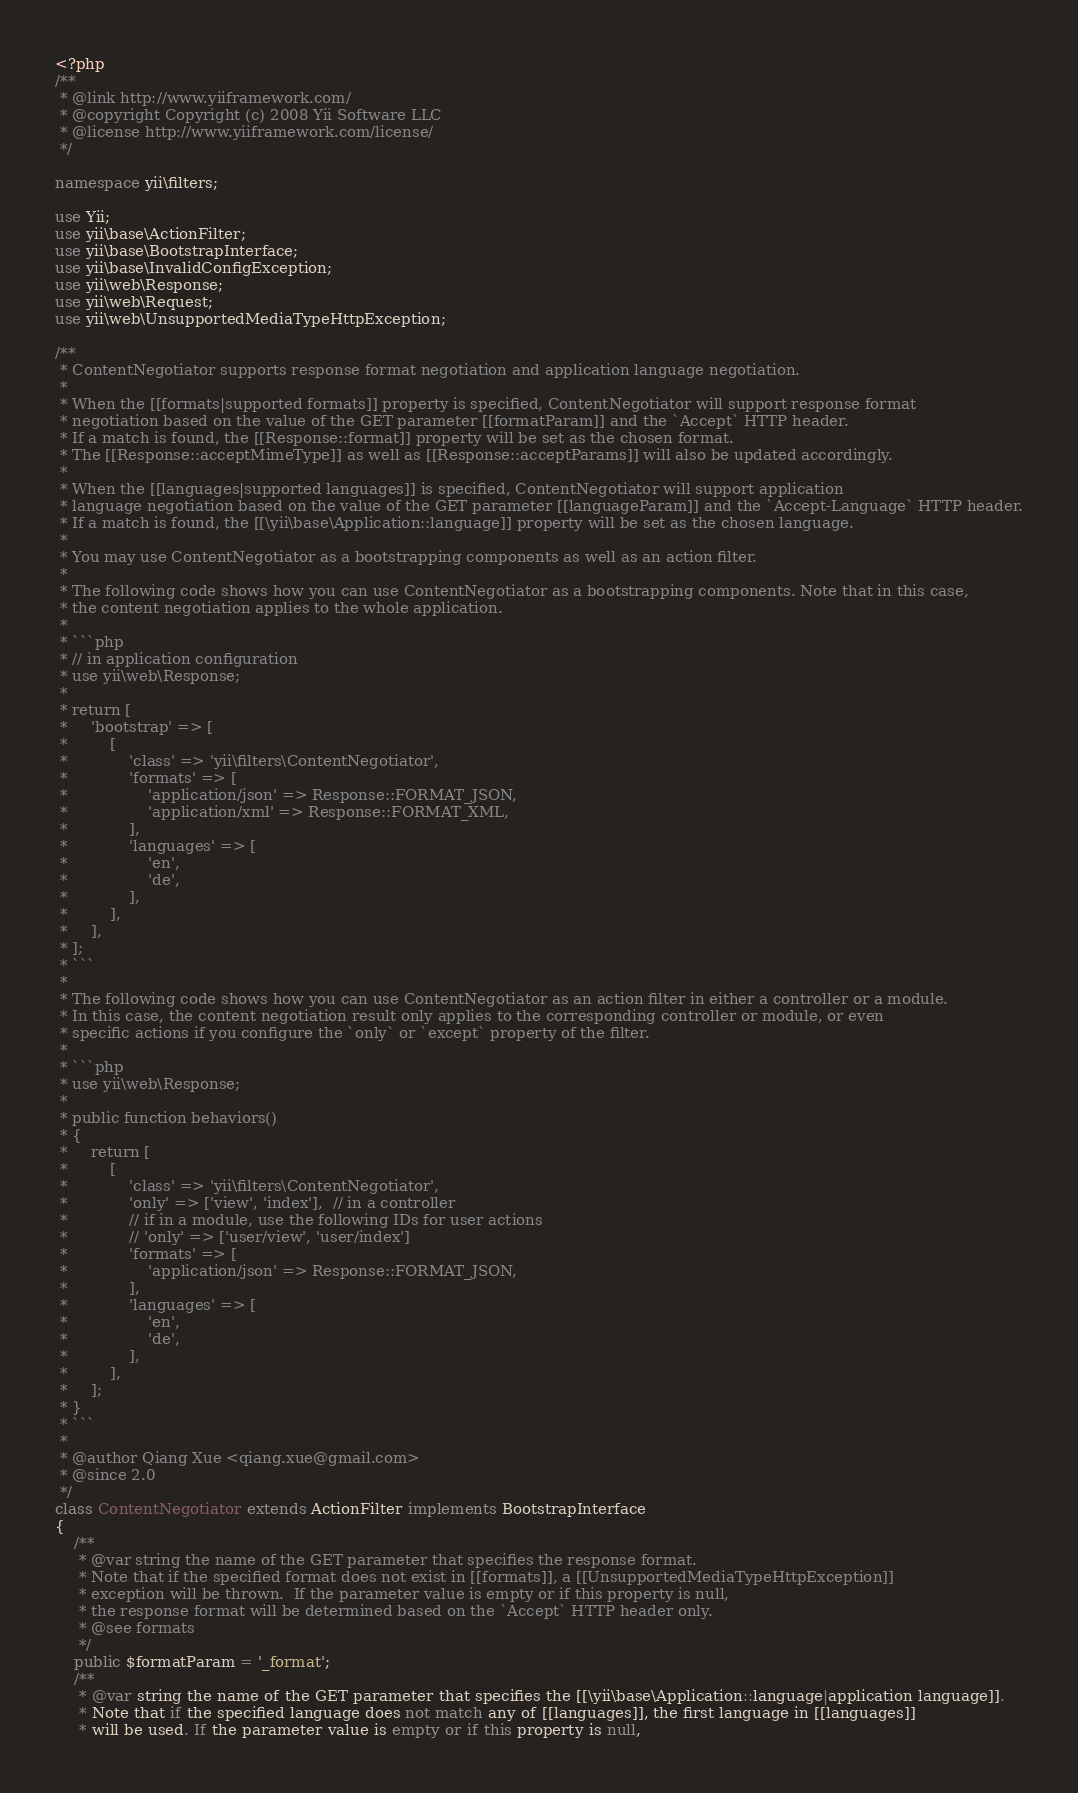<code> <loc_0><loc_0><loc_500><loc_500><_PHP_><?php
/**
 * @link http://www.yiiframework.com/
 * @copyright Copyright (c) 2008 Yii Software LLC
 * @license http://www.yiiframework.com/license/
 */

namespace yii\filters;

use Yii;
use yii\base\ActionFilter;
use yii\base\BootstrapInterface;
use yii\base\InvalidConfigException;
use yii\web\Response;
use yii\web\Request;
use yii\web\UnsupportedMediaTypeHttpException;

/**
 * ContentNegotiator supports response format negotiation and application language negotiation.
 *
 * When the [[formats|supported formats]] property is specified, ContentNegotiator will support response format
 * negotiation based on the value of the GET parameter [[formatParam]] and the `Accept` HTTP header.
 * If a match is found, the [[Response::format]] property will be set as the chosen format.
 * The [[Response::acceptMimeType]] as well as [[Response::acceptParams]] will also be updated accordingly.
 *
 * When the [[languages|supported languages]] is specified, ContentNegotiator will support application
 * language negotiation based on the value of the GET parameter [[languageParam]] and the `Accept-Language` HTTP header.
 * If a match is found, the [[\yii\base\Application::language]] property will be set as the chosen language.
 *
 * You may use ContentNegotiator as a bootstrapping components as well as an action filter.
 *
 * The following code shows how you can use ContentNegotiator as a bootstrapping components. Note that in this case,
 * the content negotiation applies to the whole application.
 *
 * ```php
 * // in application configuration
 * use yii\web\Response;
 *
 * return [
 *     'bootstrap' => [
 *         [
 *             'class' => 'yii\filters\ContentNegotiator',
 *             'formats' => [
 *                 'application/json' => Response::FORMAT_JSON,
 *                 'application/xml' => Response::FORMAT_XML,
 *             ],
 *             'languages' => [
 *                 'en',
 *                 'de',
 *             ],
 *         ],
 *     ],
 * ];
 * ```
 *
 * The following code shows how you can use ContentNegotiator as an action filter in either a controller or a module.
 * In this case, the content negotiation result only applies to the corresponding controller or module, or even
 * specific actions if you configure the `only` or `except` property of the filter.
 *
 * ```php
 * use yii\web\Response;
 *
 * public function behaviors()
 * {
 *     return [
 *         [
 *             'class' => 'yii\filters\ContentNegotiator',
 *             'only' => ['view', 'index'],  // in a controller
 *             // if in a module, use the following IDs for user actions
 *             // 'only' => ['user/view', 'user/index']
 *             'formats' => [
 *                 'application/json' => Response::FORMAT_JSON,
 *             ],
 *             'languages' => [
 *                 'en',
 *                 'de',
 *             ],
 *         ],
 *     ];
 * }
 * ```
 *
 * @author Qiang Xue <qiang.xue@gmail.com>
 * @since 2.0
 */
class ContentNegotiator extends ActionFilter implements BootstrapInterface
{
    /**
     * @var string the name of the GET parameter that specifies the response format.
     * Note that if the specified format does not exist in [[formats]], a [[UnsupportedMediaTypeHttpException]]
     * exception will be thrown.  If the parameter value is empty or if this property is null,
     * the response format will be determined based on the `Accept` HTTP header only.
     * @see formats
     */
    public $formatParam = '_format';
    /**
     * @var string the name of the GET parameter that specifies the [[\yii\base\Application::language|application language]].
     * Note that if the specified language does not match any of [[languages]], the first language in [[languages]]
     * will be used. If the parameter value is empty or if this property is null,</code> 